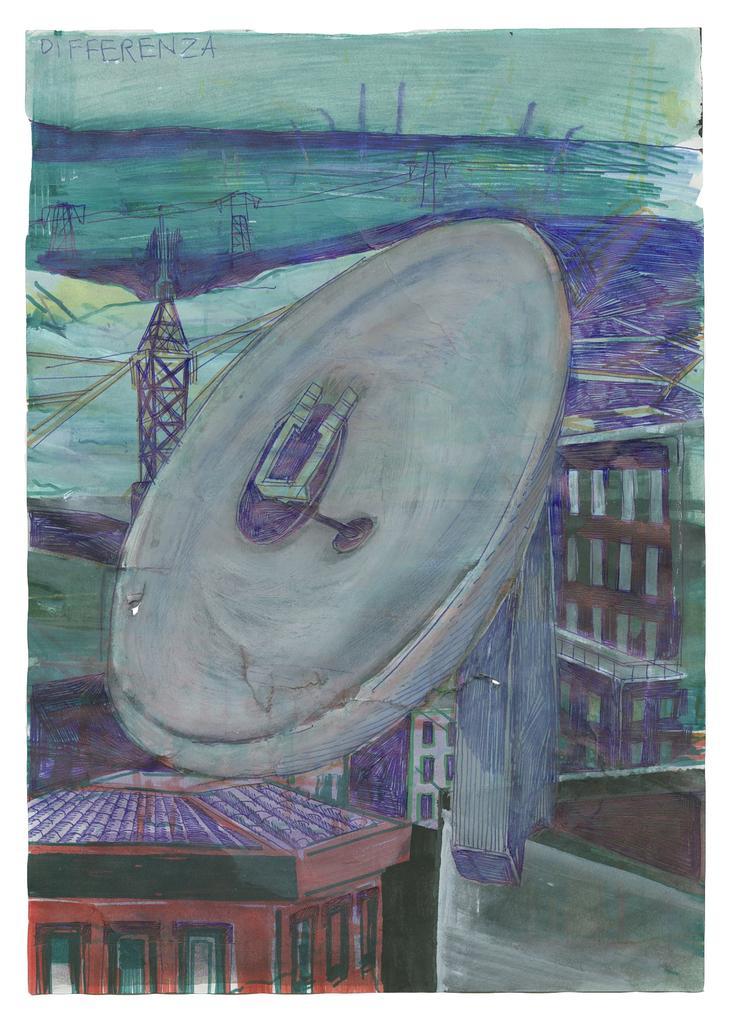How would you summarize this image in a sentence or two? In this picture we can see painting of buildings, towers and some objects. 